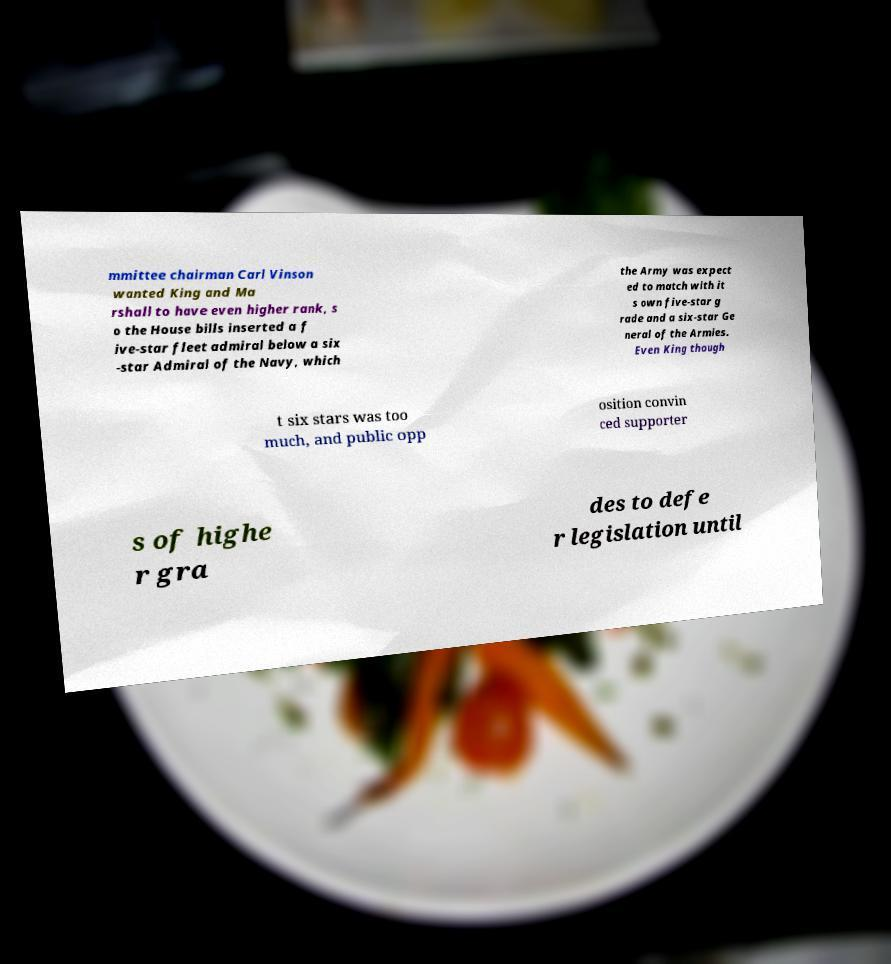Can you accurately transcribe the text from the provided image for me? mmittee chairman Carl Vinson wanted King and Ma rshall to have even higher rank, s o the House bills inserted a f ive-star fleet admiral below a six -star Admiral of the Navy, which the Army was expect ed to match with it s own five-star g rade and a six-star Ge neral of the Armies. Even King though t six stars was too much, and public opp osition convin ced supporter s of highe r gra des to defe r legislation until 